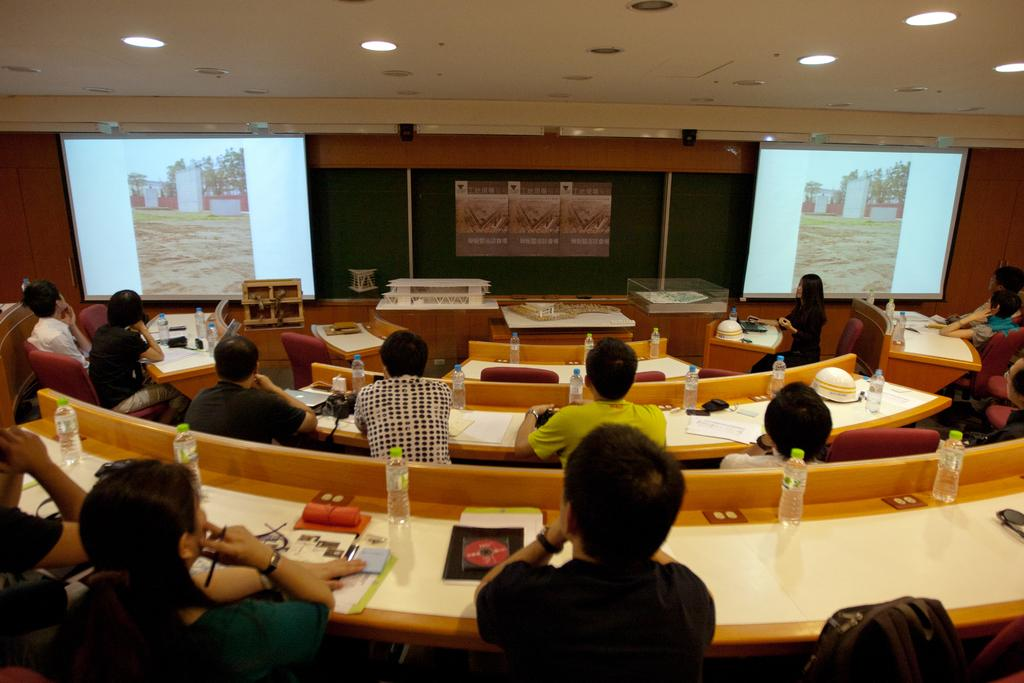What is happening in the image involving a group of people? There is a group of people in the image, and they are seated on chairs. What can be found on the table in front of the people? There are books and water bottles on the table. What is present on both sides of the image? There are projector screens on both sides of the image. What type of animal can be seen interacting with the books on the table? There is no animal present in the image; it only shows a group of people seated on chairs with books and water bottles on the table. 